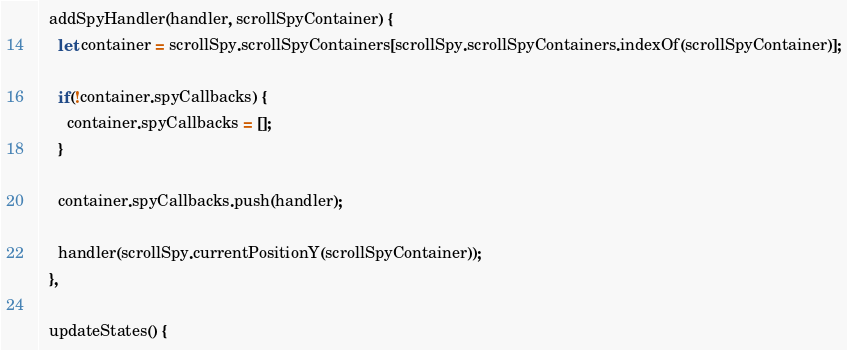<code> <loc_0><loc_0><loc_500><loc_500><_JavaScript_>
  addSpyHandler(handler, scrollSpyContainer) {
    let container = scrollSpy.scrollSpyContainers[scrollSpy.scrollSpyContainers.indexOf(scrollSpyContainer)];
    
    if(!container.spyCallbacks) {
      container.spyCallbacks = [];
    }

    container.spyCallbacks.push(handler);

    handler(scrollSpy.currentPositionY(scrollSpyContainer));
  },

  updateStates() {</code> 